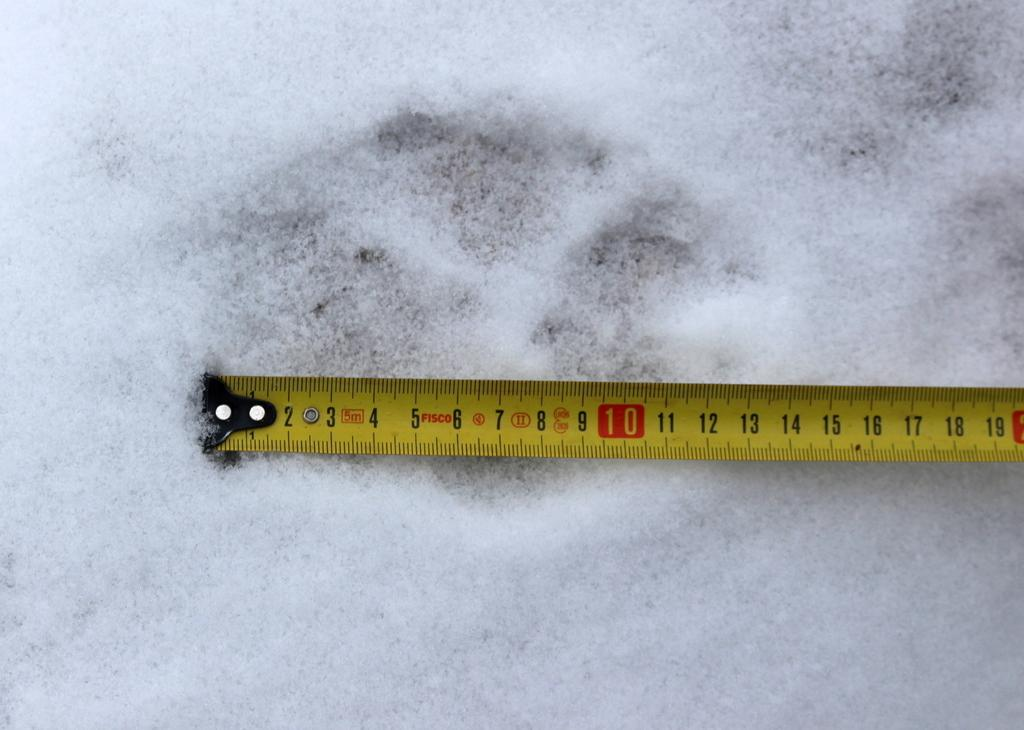<image>
Share a concise interpretation of the image provided. A Fisco brand tape measure is on a white surface. 